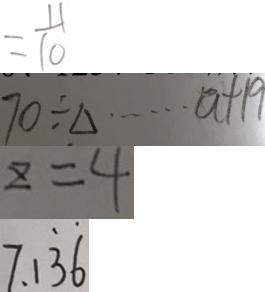Convert formula to latex. <formula><loc_0><loc_0><loc_500><loc_500>= \frac { 1 1 } { 1 0 } 
 7 0 \div \Delta \cdots a + 1 9 
 z = 4 
 7 . 1 \dot { 3 } \dot { 6 }</formula> 